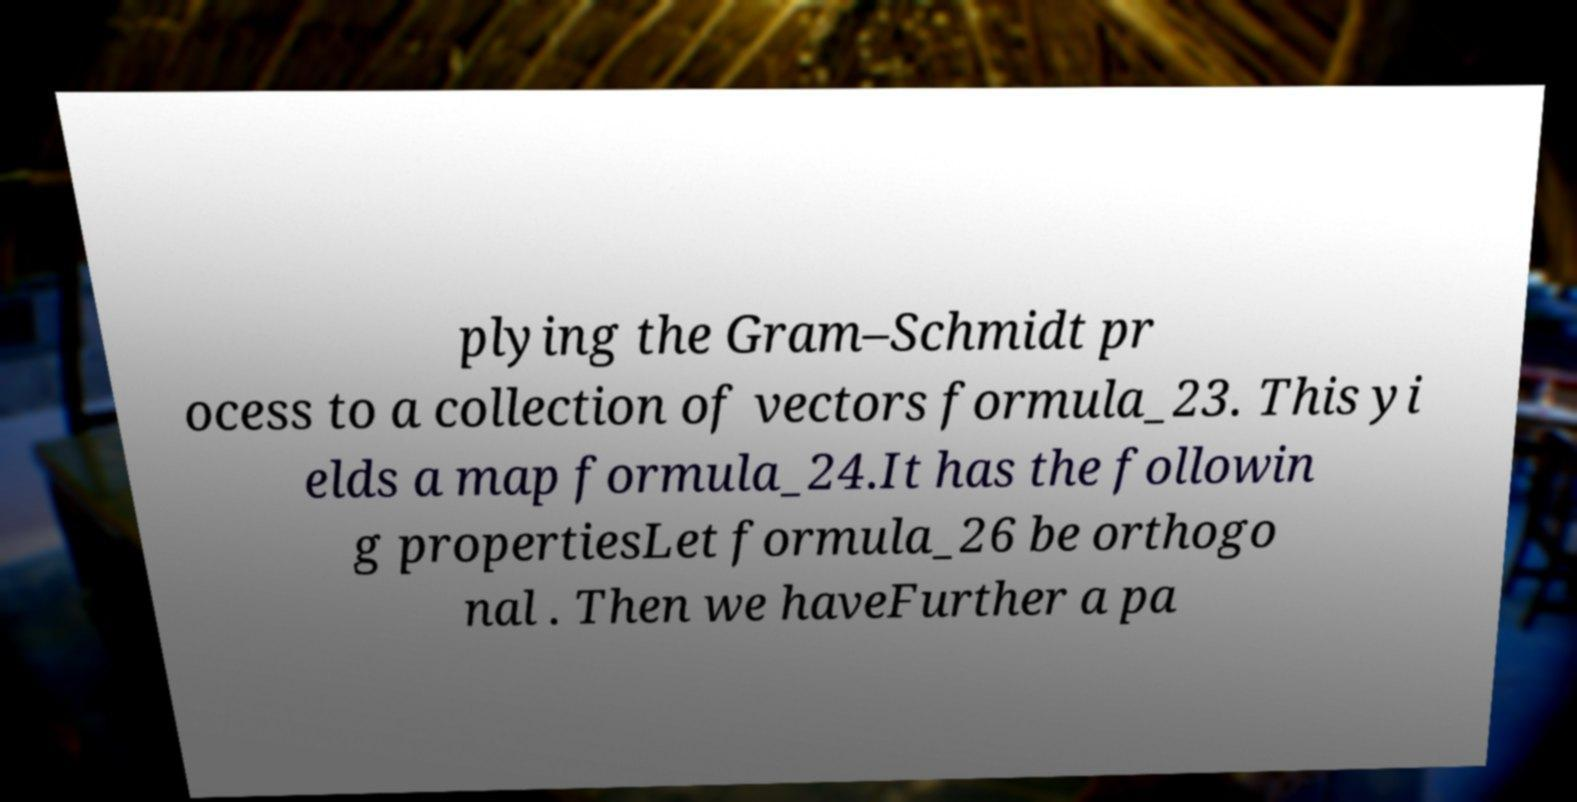Please read and relay the text visible in this image. What does it say? plying the Gram–Schmidt pr ocess to a collection of vectors formula_23. This yi elds a map formula_24.It has the followin g propertiesLet formula_26 be orthogo nal . Then we haveFurther a pa 